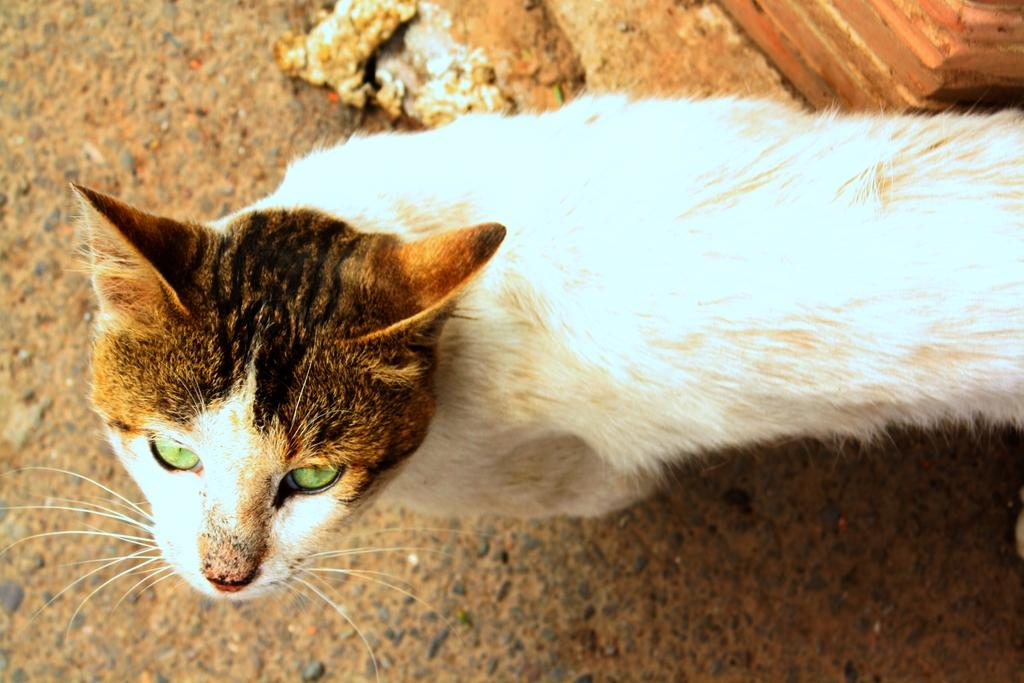What type of animal is present in the image? There is a cat in the image. Can you describe the color pattern of the cat? The cat is colored white and brown. What type of cent can be seen in the image? There is no cent present in the image; it features a cat. What type of mother can be seen in the image? There is no mother present in the image; it features a cat. 